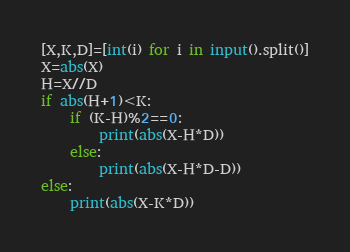Convert code to text. <code><loc_0><loc_0><loc_500><loc_500><_Python_>[X,K,D]=[int(i) for i in input().split()]
X=abs(X)
H=X//D
if abs(H+1)<K:
	if (K-H)%2==0:
		print(abs(X-H*D))
	else:
		print(abs(X-H*D-D))
else:
	print(abs(X-K*D))</code> 